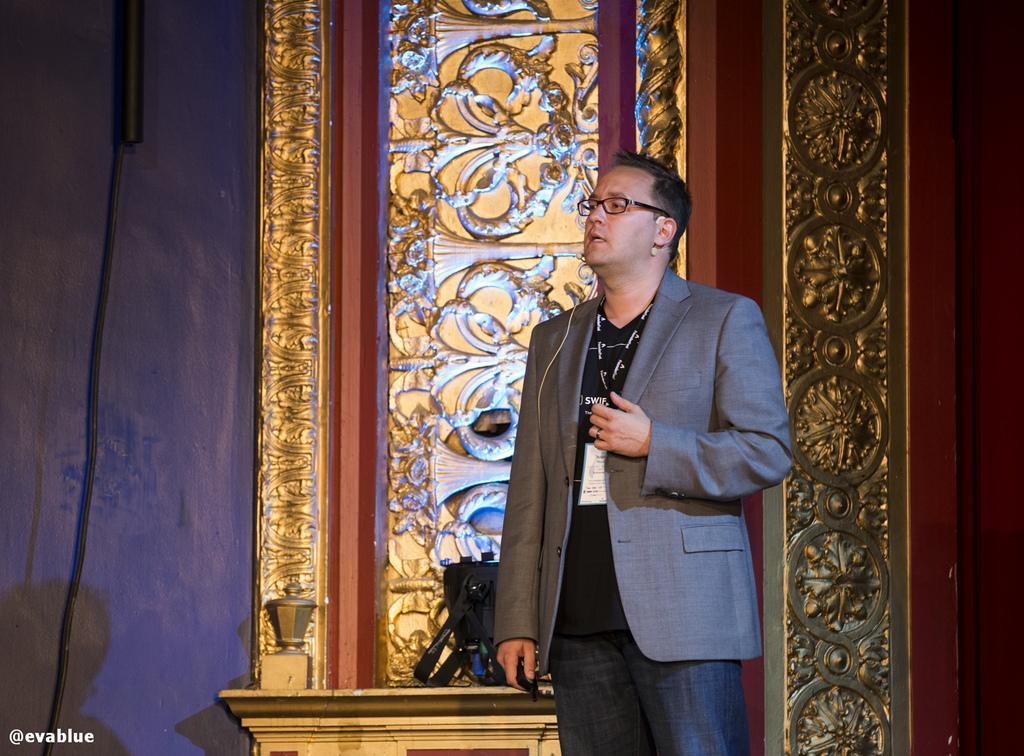Describe this image in one or two sentences. In this image I can see the person standing and wearing the grey and black color dress and also the specs. To the side I can see the black color bag. In the back there is a gold and brown color object to the wall. 